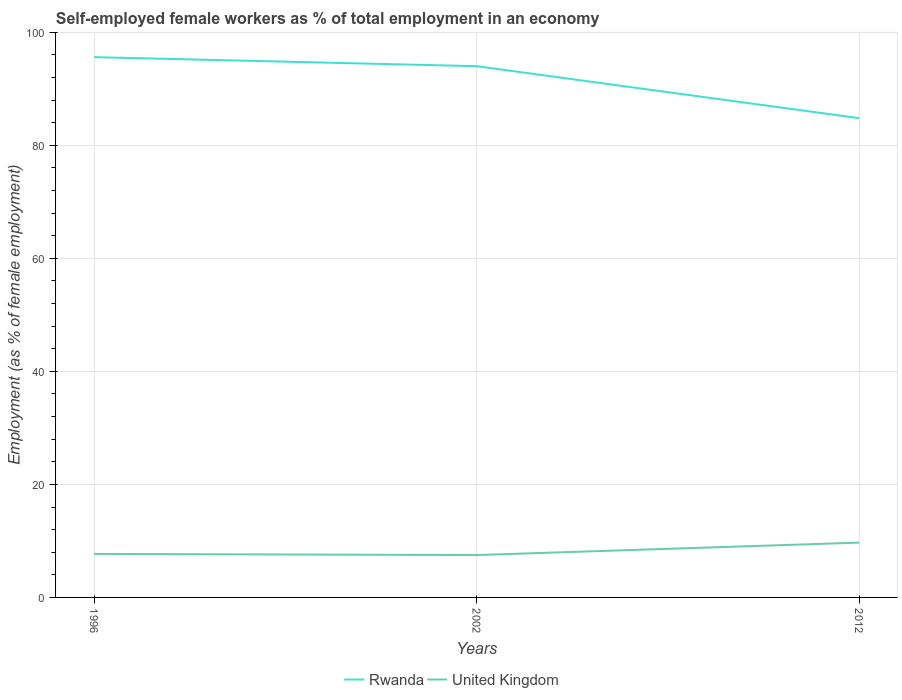Is the number of lines equal to the number of legend labels?
Your answer should be compact. Yes. Across all years, what is the maximum percentage of self-employed female workers in Rwanda?
Keep it short and to the point. 84.8. In which year was the percentage of self-employed female workers in Rwanda maximum?
Provide a short and direct response. 2012. What is the total percentage of self-employed female workers in Rwanda in the graph?
Your response must be concise. 9.2. What is the difference between the highest and the second highest percentage of self-employed female workers in Rwanda?
Your answer should be very brief. 10.8. What is the difference between two consecutive major ticks on the Y-axis?
Your answer should be very brief. 20. Are the values on the major ticks of Y-axis written in scientific E-notation?
Keep it short and to the point. No. Does the graph contain any zero values?
Offer a terse response. No. Does the graph contain grids?
Keep it short and to the point. Yes. Where does the legend appear in the graph?
Your answer should be compact. Bottom center. What is the title of the graph?
Your answer should be very brief. Self-employed female workers as % of total employment in an economy. Does "Israel" appear as one of the legend labels in the graph?
Ensure brevity in your answer.  No. What is the label or title of the Y-axis?
Ensure brevity in your answer.  Employment (as % of female employment). What is the Employment (as % of female employment) in Rwanda in 1996?
Ensure brevity in your answer.  95.6. What is the Employment (as % of female employment) in United Kingdom in 1996?
Make the answer very short. 7.7. What is the Employment (as % of female employment) of Rwanda in 2002?
Provide a short and direct response. 94. What is the Employment (as % of female employment) in Rwanda in 2012?
Make the answer very short. 84.8. What is the Employment (as % of female employment) of United Kingdom in 2012?
Ensure brevity in your answer.  9.7. Across all years, what is the maximum Employment (as % of female employment) of Rwanda?
Your answer should be very brief. 95.6. Across all years, what is the maximum Employment (as % of female employment) in United Kingdom?
Your answer should be very brief. 9.7. Across all years, what is the minimum Employment (as % of female employment) of Rwanda?
Your response must be concise. 84.8. What is the total Employment (as % of female employment) of Rwanda in the graph?
Provide a short and direct response. 274.4. What is the total Employment (as % of female employment) of United Kingdom in the graph?
Offer a very short reply. 24.9. What is the difference between the Employment (as % of female employment) in Rwanda in 1996 and that in 2002?
Your answer should be compact. 1.6. What is the difference between the Employment (as % of female employment) of United Kingdom in 1996 and that in 2002?
Provide a short and direct response. 0.2. What is the difference between the Employment (as % of female employment) in United Kingdom in 1996 and that in 2012?
Keep it short and to the point. -2. What is the difference between the Employment (as % of female employment) of Rwanda in 1996 and the Employment (as % of female employment) of United Kingdom in 2002?
Your answer should be compact. 88.1. What is the difference between the Employment (as % of female employment) of Rwanda in 1996 and the Employment (as % of female employment) of United Kingdom in 2012?
Offer a very short reply. 85.9. What is the difference between the Employment (as % of female employment) of Rwanda in 2002 and the Employment (as % of female employment) of United Kingdom in 2012?
Provide a short and direct response. 84.3. What is the average Employment (as % of female employment) of Rwanda per year?
Give a very brief answer. 91.47. In the year 1996, what is the difference between the Employment (as % of female employment) in Rwanda and Employment (as % of female employment) in United Kingdom?
Your answer should be very brief. 87.9. In the year 2002, what is the difference between the Employment (as % of female employment) of Rwanda and Employment (as % of female employment) of United Kingdom?
Keep it short and to the point. 86.5. In the year 2012, what is the difference between the Employment (as % of female employment) of Rwanda and Employment (as % of female employment) of United Kingdom?
Provide a short and direct response. 75.1. What is the ratio of the Employment (as % of female employment) of Rwanda in 1996 to that in 2002?
Offer a terse response. 1.02. What is the ratio of the Employment (as % of female employment) of United Kingdom in 1996 to that in 2002?
Keep it short and to the point. 1.03. What is the ratio of the Employment (as % of female employment) in Rwanda in 1996 to that in 2012?
Keep it short and to the point. 1.13. What is the ratio of the Employment (as % of female employment) of United Kingdom in 1996 to that in 2012?
Ensure brevity in your answer.  0.79. What is the ratio of the Employment (as % of female employment) of Rwanda in 2002 to that in 2012?
Provide a short and direct response. 1.11. What is the ratio of the Employment (as % of female employment) of United Kingdom in 2002 to that in 2012?
Your answer should be very brief. 0.77. What is the difference between the highest and the second highest Employment (as % of female employment) of Rwanda?
Offer a very short reply. 1.6. What is the difference between the highest and the lowest Employment (as % of female employment) of Rwanda?
Your response must be concise. 10.8. 